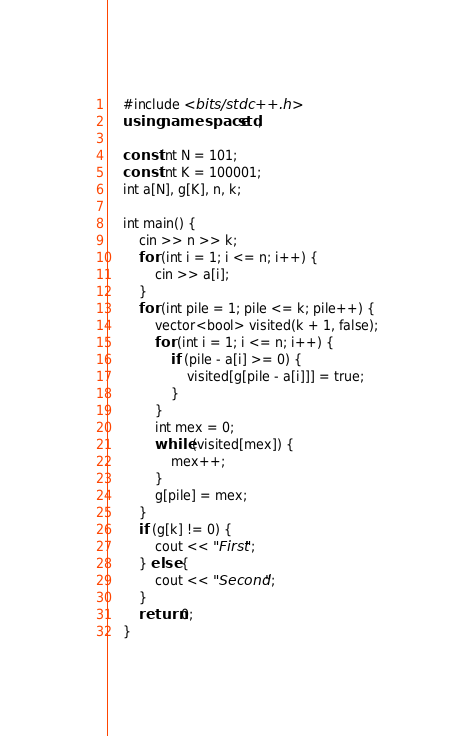<code> <loc_0><loc_0><loc_500><loc_500><_C++_>    #include <bits/stdc++.h>
    using namespace std;
     
    const int N = 101;
    const int K = 100001;
    int a[N], g[K], n, k;
     
    int main() {
        cin >> n >> k;
        for (int i = 1; i <= n; i++) {
            cin >> a[i];
        }
        for (int pile = 1; pile <= k; pile++) {
            vector<bool> visited(k + 1, false);
            for (int i = 1; i <= n; i++) {
                if (pile - a[i] >= 0) {
                    visited[g[pile - a[i]]] = true;
                }
            }
            int mex = 0;
            while (visited[mex]) {
                mex++;
            }
            g[pile] = mex;
        }
        if (g[k] != 0) {
            cout << "First";
        } else {
            cout << "Second";
        }
        return 0;
    }</code> 